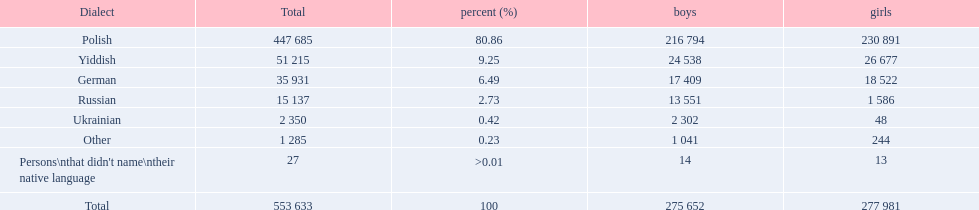How many speakers are represented in polish? 447 685. How many represented speakers are yiddish? 51 215. What is the total number of speakers? 553 633. 